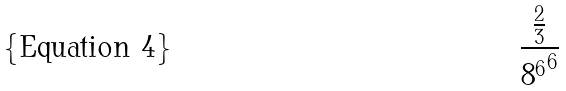<formula> <loc_0><loc_0><loc_500><loc_500>\frac { \frac { 2 } { 3 } } { { 8 ^ { 6 } } ^ { 6 } }</formula> 